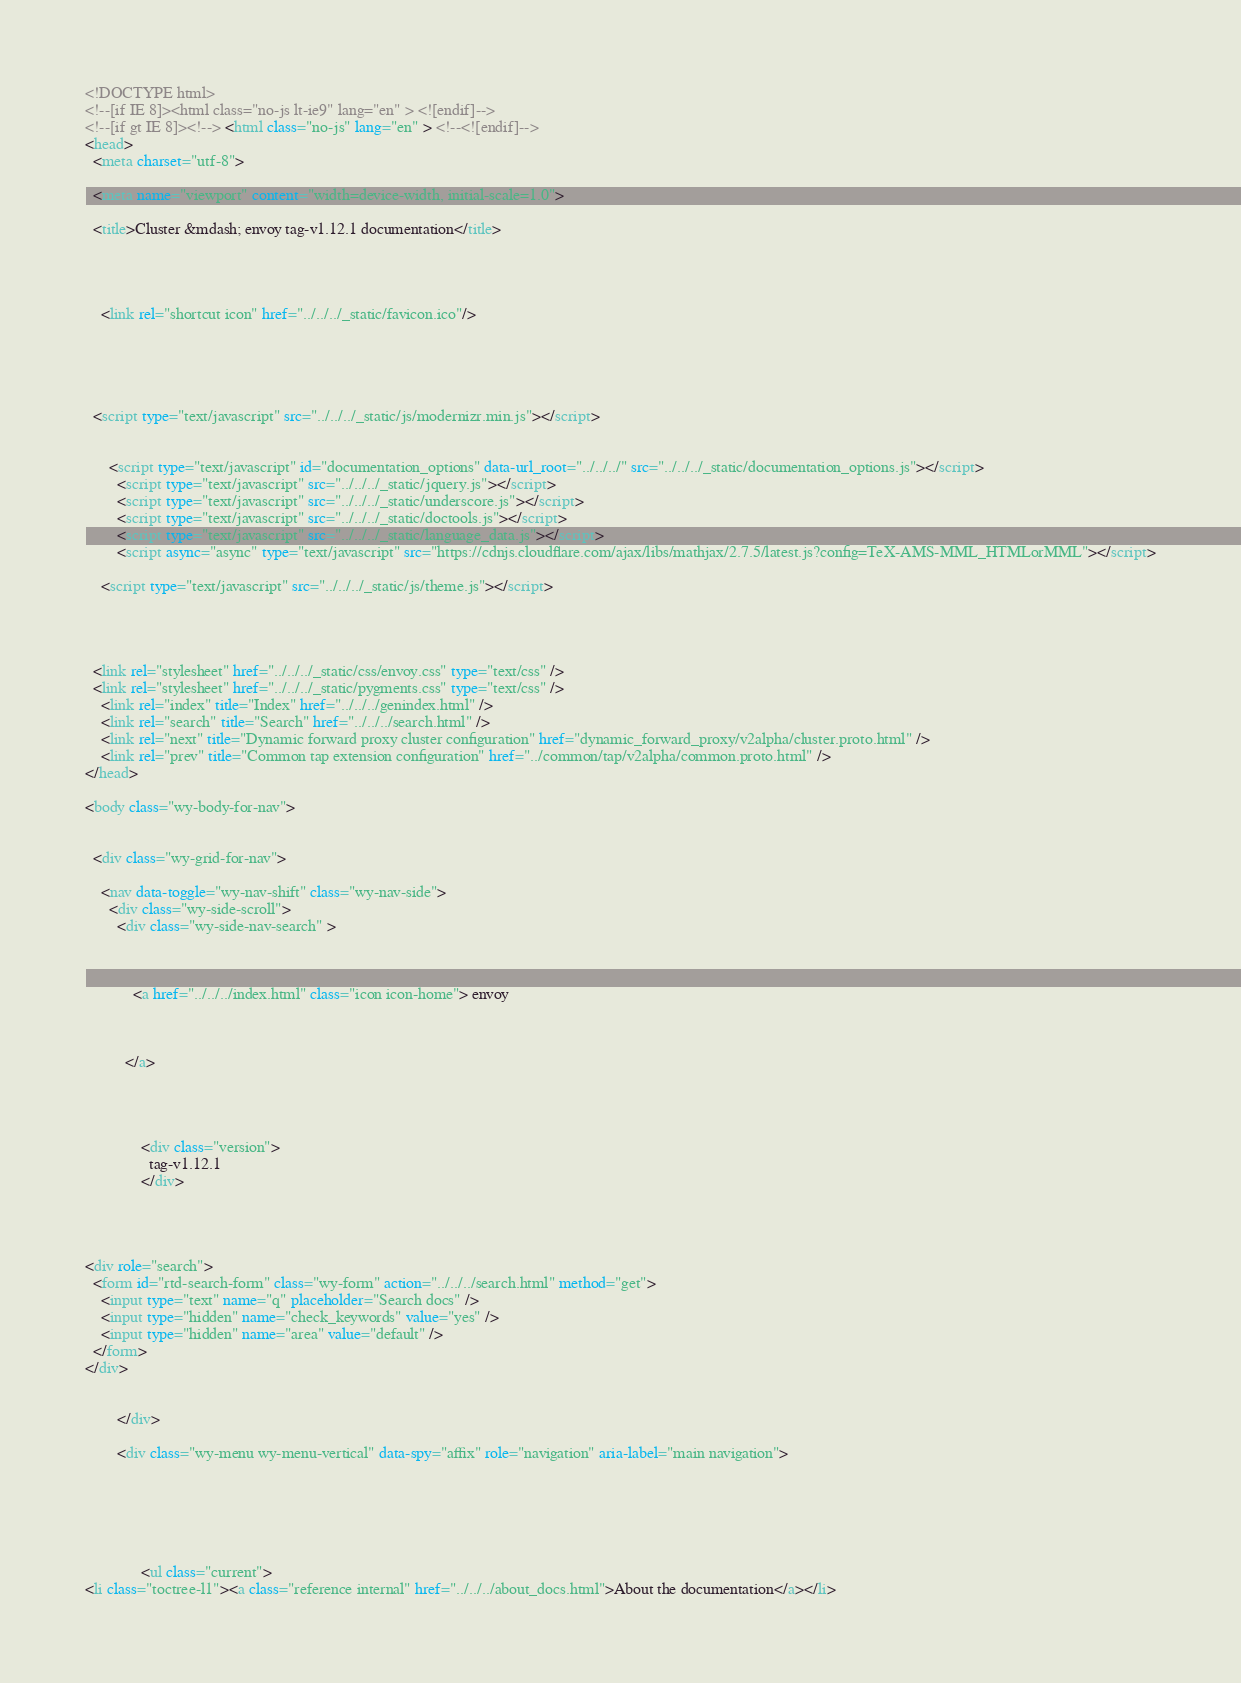Convert code to text. <code><loc_0><loc_0><loc_500><loc_500><_HTML_>

<!DOCTYPE html>
<!--[if IE 8]><html class="no-js lt-ie9" lang="en" > <![endif]-->
<!--[if gt IE 8]><!--> <html class="no-js" lang="en" > <!--<![endif]-->
<head>
  <meta charset="utf-8">
  
  <meta name="viewport" content="width=device-width, initial-scale=1.0">
  
  <title>Cluster &mdash; envoy tag-v1.12.1 documentation</title>
  

  
  
    <link rel="shortcut icon" href="../../../_static/favicon.ico"/>
  
  
  

  
  <script type="text/javascript" src="../../../_static/js/modernizr.min.js"></script>
  
    
      <script type="text/javascript" id="documentation_options" data-url_root="../../../" src="../../../_static/documentation_options.js"></script>
        <script type="text/javascript" src="../../../_static/jquery.js"></script>
        <script type="text/javascript" src="../../../_static/underscore.js"></script>
        <script type="text/javascript" src="../../../_static/doctools.js"></script>
        <script type="text/javascript" src="../../../_static/language_data.js"></script>
        <script async="async" type="text/javascript" src="https://cdnjs.cloudflare.com/ajax/libs/mathjax/2.7.5/latest.js?config=TeX-AMS-MML_HTMLorMML"></script>
    
    <script type="text/javascript" src="../../../_static/js/theme.js"></script>

    

  
  <link rel="stylesheet" href="../../../_static/css/envoy.css" type="text/css" />
  <link rel="stylesheet" href="../../../_static/pygments.css" type="text/css" />
    <link rel="index" title="Index" href="../../../genindex.html" />
    <link rel="search" title="Search" href="../../../search.html" />
    <link rel="next" title="Dynamic forward proxy cluster configuration" href="dynamic_forward_proxy/v2alpha/cluster.proto.html" />
    <link rel="prev" title="Common tap extension configuration" href="../common/tap/v2alpha/common.proto.html" /> 
</head>

<body class="wy-body-for-nav">

   
  <div class="wy-grid-for-nav">
    
    <nav data-toggle="wy-nav-shift" class="wy-nav-side">
      <div class="wy-side-scroll">
        <div class="wy-side-nav-search" >
          

          
            <a href="../../../index.html" class="icon icon-home"> envoy
          

          
          </a>

          
            
            
              <div class="version">
                tag-v1.12.1
              </div>
            
          

          
<div role="search">
  <form id="rtd-search-form" class="wy-form" action="../../../search.html" method="get">
    <input type="text" name="q" placeholder="Search docs" />
    <input type="hidden" name="check_keywords" value="yes" />
    <input type="hidden" name="area" value="default" />
  </form>
</div>

          
        </div>

        <div class="wy-menu wy-menu-vertical" data-spy="affix" role="navigation" aria-label="main navigation">
          
            
            
              
            
            
              <ul class="current">
<li class="toctree-l1"><a class="reference internal" href="../../../about_docs.html">About the documentation</a></li></code> 